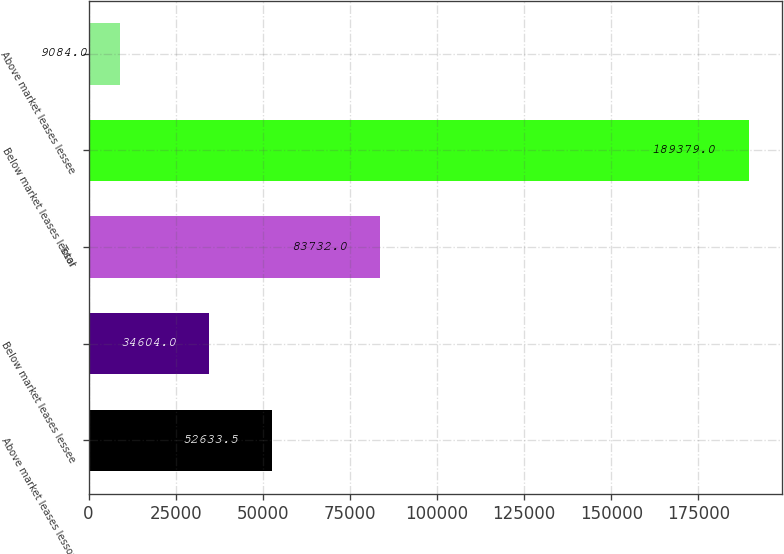<chart> <loc_0><loc_0><loc_500><loc_500><bar_chart><fcel>Above market leases lessor<fcel>Below market leases lessee<fcel>Total<fcel>Below market leases lessor<fcel>Above market leases lessee<nl><fcel>52633.5<fcel>34604<fcel>83732<fcel>189379<fcel>9084<nl></chart> 